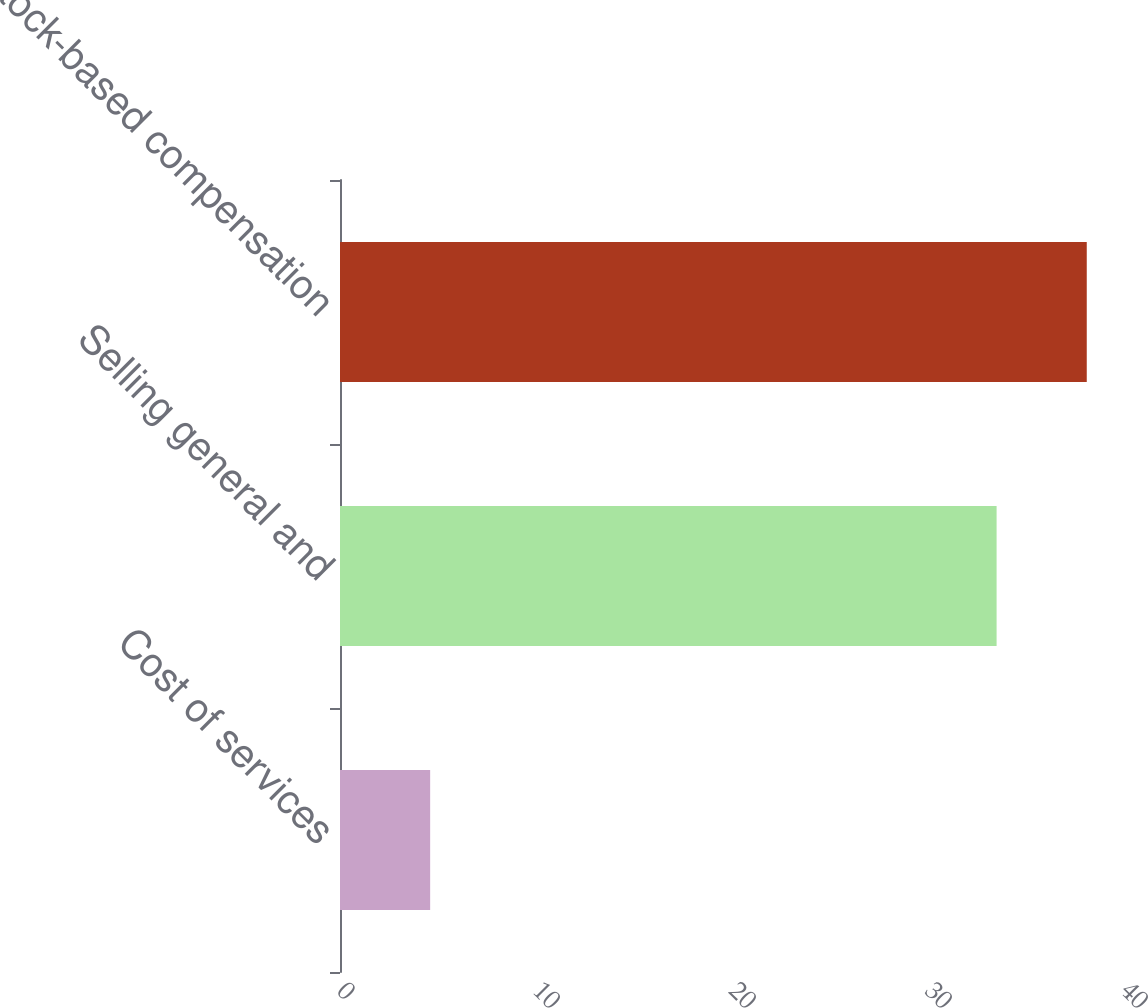Convert chart to OTSL. <chart><loc_0><loc_0><loc_500><loc_500><bar_chart><fcel>Cost of services<fcel>Selling general and<fcel>Stock-based compensation<nl><fcel>4.6<fcel>33.5<fcel>38.1<nl></chart> 